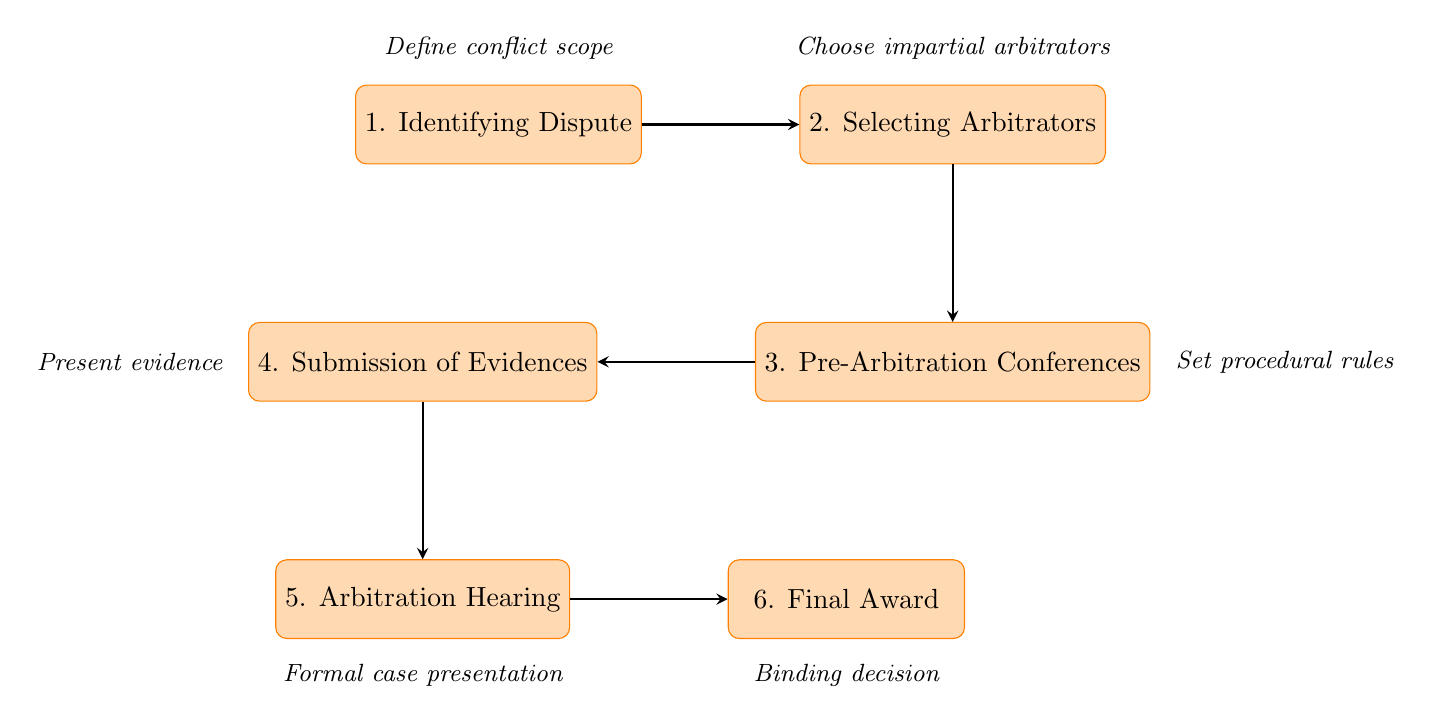What is the first step in the arbitration process? The first step depicted in the flowchart is "Identifying Dispute." This is explicitly mentioned as the first node in the diagram, leading the flow of the arbitration process.
Answer: Identifying Dispute How many nodes are there in the diagram? The diagram consists of six nodes that represent different steps in the judicial arbitration process. Each step is outlined individually, contributing to the overall flow of the diagram.
Answer: Six What step follows "Submission of Evidences"? According to the flowchart, the step that follows "Submission of Evidences" is "Arbitration Hearing." This is a direct connection in the flow, indicating the chronological order of the process.
Answer: Arbitration Hearing What is the final output of the arbitration process? The end point of the flowchart indicates that the final output is "Final Award." This is stated in the last node of the flowchart, representing the conclusion of the arbitration proceedings.
Answer: Final Award What describes the purpose of the "Pre-Arbitration Conferences"? The purpose of the "Pre-Arbitration Conferences" is to "Set procedural rules." This detail is noted just above that node in the flowchart, indicating what will be organized in those meetings.
Answer: Set procedural rules Which step involves the choice of arbitrators? The step involving the choice of arbitrators is "Selecting Arbitrators." This node specifically addresses the selection process for impartial and qualified individuals who oversee arbitration.
Answer: Selecting Arbitrators What is required before the "Arbitration Hearing" can take place? Before the "Arbitration Hearing" can take place, the step "Submission of Evidences" must occur. This is sequentially illustrated in the flowchart as an essential prerequisite for the hearing.
Answer: Submission of Evidences How many steps are there between "Identifying Dispute" and "Final Award"? There are five steps between "Identifying Dispute" and "Final Award," as shown by the flow of the diagram moving from the first to the last step sequentially through all intermediate stages.
Answer: Five What important aspect is discussed during the "Pre-Arbitration Conferences"? The important aspect discussed during the "Pre-Arbitration Conferences" is "Confidentiality agreements." This is one of the key points noted under that stage in the flowchart, highlighting its significance in the process.
Answer: Confidentiality agreements 